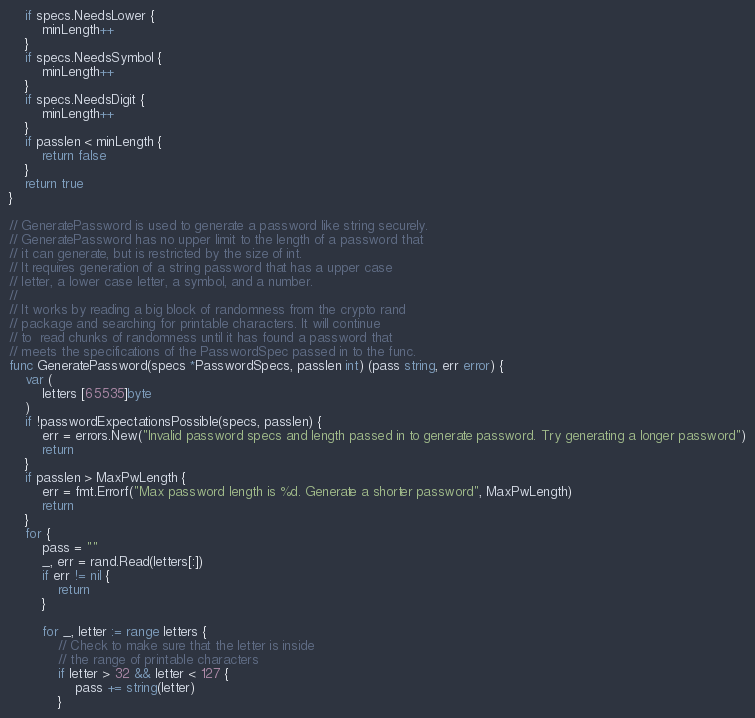Convert code to text. <code><loc_0><loc_0><loc_500><loc_500><_Go_>	if specs.NeedsLower {
		minLength++
	}
	if specs.NeedsSymbol {
		minLength++
	}
	if specs.NeedsDigit {
		minLength++
	}
	if passlen < minLength {
		return false
	}
	return true
}

// GeneratePassword is used to generate a password like string securely.
// GeneratePassword has no upper limit to the length of a password that
// it can generate, but is restricted by the size of int.
// It requires generation of a string password that has a upper case
// letter, a lower case letter, a symbol, and a number.
//
// It works by reading a big block of randomness from the crypto rand
// package and searching for printable characters. It will continue
// to  read chunks of randomness until it has found a password that
// meets the specifications of the PasswordSpec passed in to the func.
func GeneratePassword(specs *PasswordSpecs, passlen int) (pass string, err error) {
	var (
		letters [65535]byte
	)
	if !passwordExpectationsPossible(specs, passlen) {
		err = errors.New("Invalid password specs and length passed in to generate password. Try generating a longer password")
		return
	}
	if passlen > MaxPwLength {
		err = fmt.Errorf("Max password length is %d. Generate a shorter password", MaxPwLength)
		return
	}
	for {
		pass = ""
		_, err = rand.Read(letters[:])
		if err != nil {
			return
		}

		for _, letter := range letters {
			// Check to make sure that the letter is inside
			// the range of printable characters
			if letter > 32 && letter < 127 {
				pass += string(letter)
			}</code> 